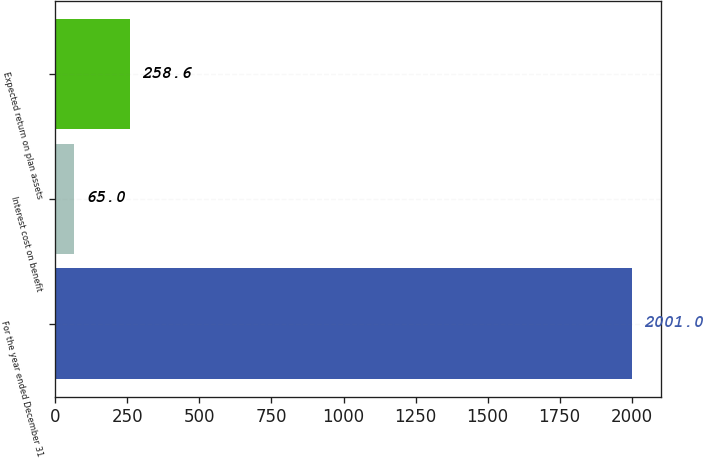Convert chart to OTSL. <chart><loc_0><loc_0><loc_500><loc_500><bar_chart><fcel>For the year ended December 31<fcel>Interest cost on benefit<fcel>Expected return on plan assets<nl><fcel>2001<fcel>65<fcel>258.6<nl></chart> 